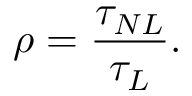<formula> <loc_0><loc_0><loc_500><loc_500>\rho = \frac { \tau _ { N L } } { \tau _ { L } } .</formula> 